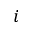<formula> <loc_0><loc_0><loc_500><loc_500>i</formula> 